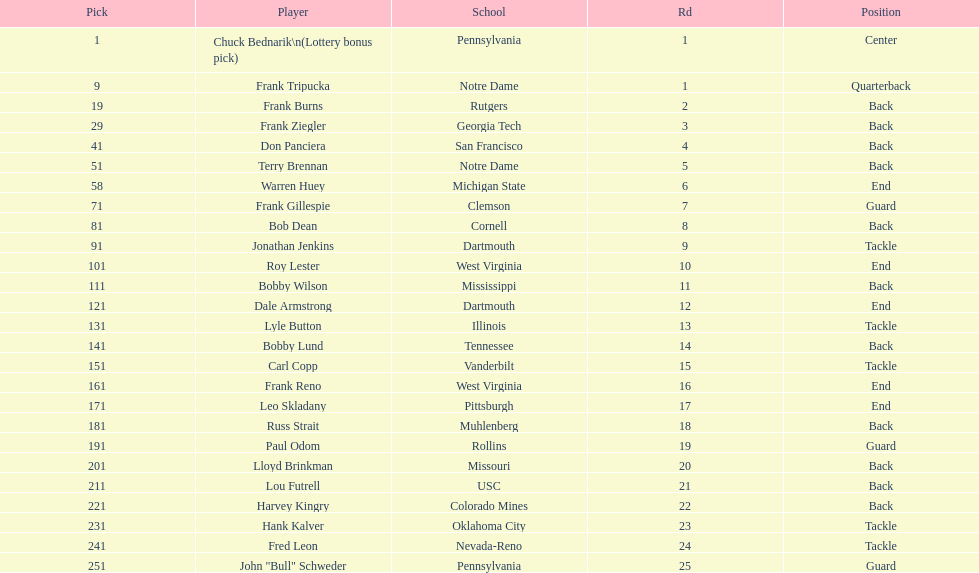How many players were from notre dame? 2. Could you help me parse every detail presented in this table? {'header': ['Pick', 'Player', 'School', 'Rd', 'Position'], 'rows': [['1', 'Chuck Bednarik\\n(Lottery bonus pick)', 'Pennsylvania', '1', 'Center'], ['9', 'Frank Tripucka', 'Notre Dame', '1', 'Quarterback'], ['19', 'Frank Burns', 'Rutgers', '2', 'Back'], ['29', 'Frank Ziegler', 'Georgia Tech', '3', 'Back'], ['41', 'Don Panciera', 'San Francisco', '4', 'Back'], ['51', 'Terry Brennan', 'Notre Dame', '5', 'Back'], ['58', 'Warren Huey', 'Michigan State', '6', 'End'], ['71', 'Frank Gillespie', 'Clemson', '7', 'Guard'], ['81', 'Bob Dean', 'Cornell', '8', 'Back'], ['91', 'Jonathan Jenkins', 'Dartmouth', '9', 'Tackle'], ['101', 'Roy Lester', 'West Virginia', '10', 'End'], ['111', 'Bobby Wilson', 'Mississippi', '11', 'Back'], ['121', 'Dale Armstrong', 'Dartmouth', '12', 'End'], ['131', 'Lyle Button', 'Illinois', '13', 'Tackle'], ['141', 'Bobby Lund', 'Tennessee', '14', 'Back'], ['151', 'Carl Copp', 'Vanderbilt', '15', 'Tackle'], ['161', 'Frank Reno', 'West Virginia', '16', 'End'], ['171', 'Leo Skladany', 'Pittsburgh', '17', 'End'], ['181', 'Russ Strait', 'Muhlenberg', '18', 'Back'], ['191', 'Paul Odom', 'Rollins', '19', 'Guard'], ['201', 'Lloyd Brinkman', 'Missouri', '20', 'Back'], ['211', 'Lou Futrell', 'USC', '21', 'Back'], ['221', 'Harvey Kingry', 'Colorado Mines', '22', 'Back'], ['231', 'Hank Kalver', 'Oklahoma City', '23', 'Tackle'], ['241', 'Fred Leon', 'Nevada-Reno', '24', 'Tackle'], ['251', 'John "Bull" Schweder', 'Pennsylvania', '25', 'Guard']]} 